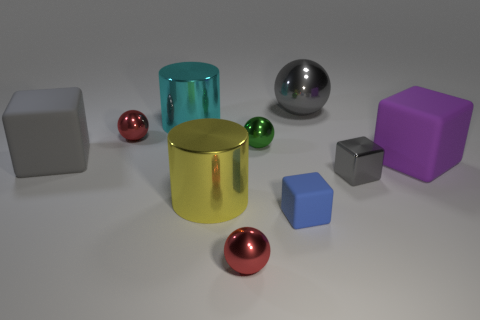There is a matte cube behind the rubber object on the right side of the large sphere; how big is it?
Provide a succinct answer. Large. Is there another small thing made of the same material as the purple thing?
Offer a terse response. Yes. What is the material of the blue object that is the same size as the metallic block?
Give a very brief answer. Rubber. Is the color of the matte thing that is on the left side of the large yellow metal object the same as the shiny block that is behind the large yellow thing?
Offer a very short reply. Yes. There is a red thing that is in front of the big purple thing; are there any big purple rubber blocks that are behind it?
Offer a very short reply. Yes. Does the gray metal object behind the metal block have the same shape as the gray thing to the left of the blue thing?
Offer a very short reply. No. Do the red thing that is in front of the large yellow thing and the big gray object to the left of the big gray sphere have the same material?
Provide a succinct answer. No. There is a cube that is to the left of the red metallic sphere in front of the tiny green metal object; what is it made of?
Give a very brief answer. Rubber. What shape is the red thing that is to the left of the big cylinder that is in front of the big metallic cylinder that is behind the small gray object?
Your answer should be very brief. Sphere. What is the material of the big gray thing that is the same shape as the small blue object?
Your answer should be very brief. Rubber. 